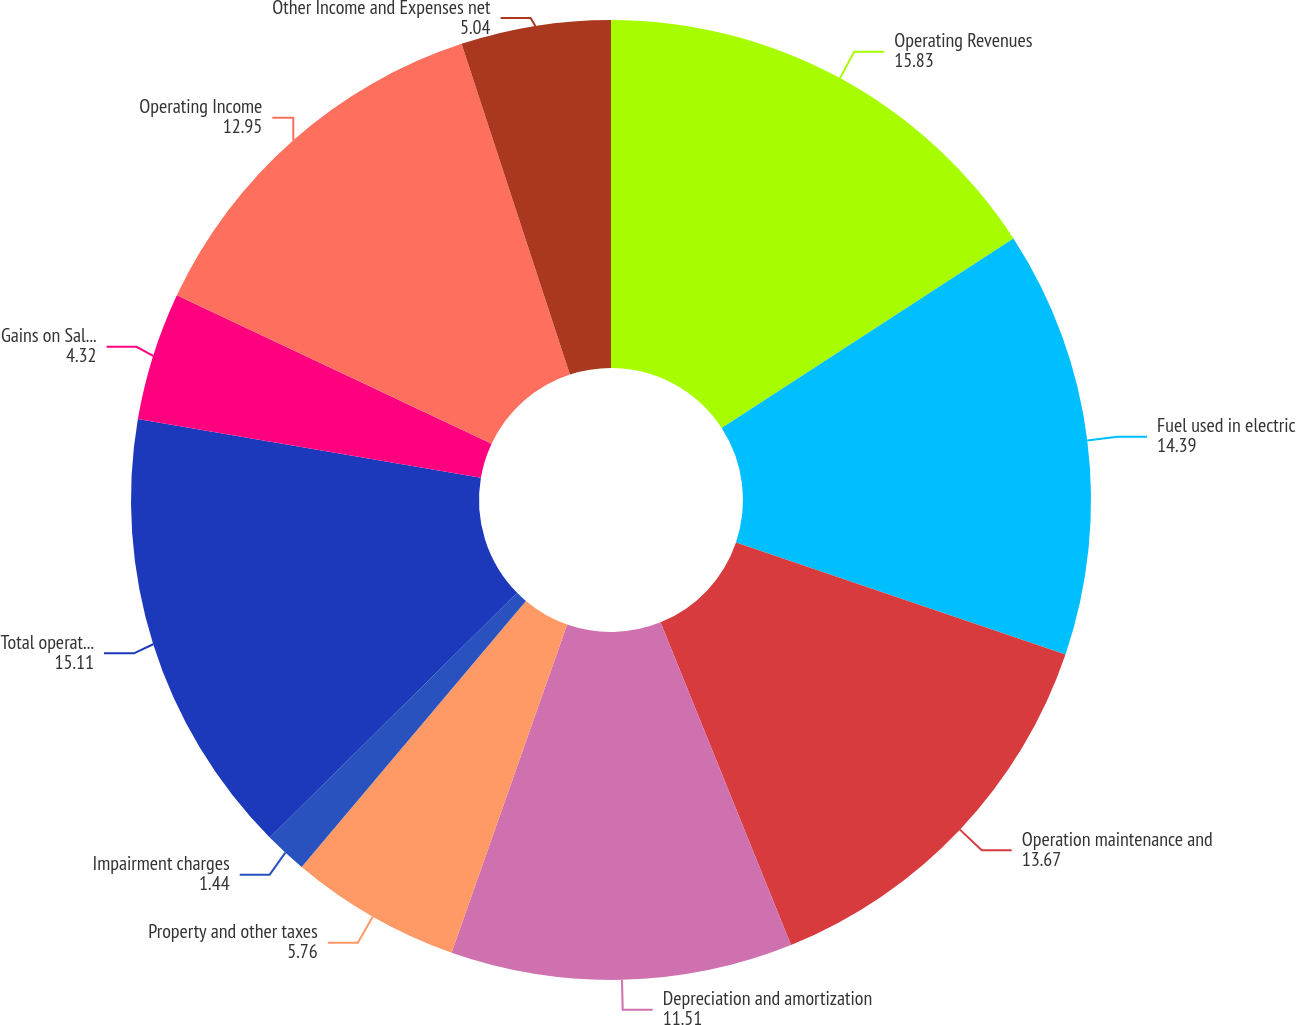Convert chart. <chart><loc_0><loc_0><loc_500><loc_500><pie_chart><fcel>Operating Revenues<fcel>Fuel used in electric<fcel>Operation maintenance and<fcel>Depreciation and amortization<fcel>Property and other taxes<fcel>Impairment charges<fcel>Total operating expenses<fcel>Gains on Sales of Other Assets<fcel>Operating Income<fcel>Other Income and Expenses net<nl><fcel>15.83%<fcel>14.39%<fcel>13.67%<fcel>11.51%<fcel>5.76%<fcel>1.44%<fcel>15.11%<fcel>4.32%<fcel>12.95%<fcel>5.04%<nl></chart> 